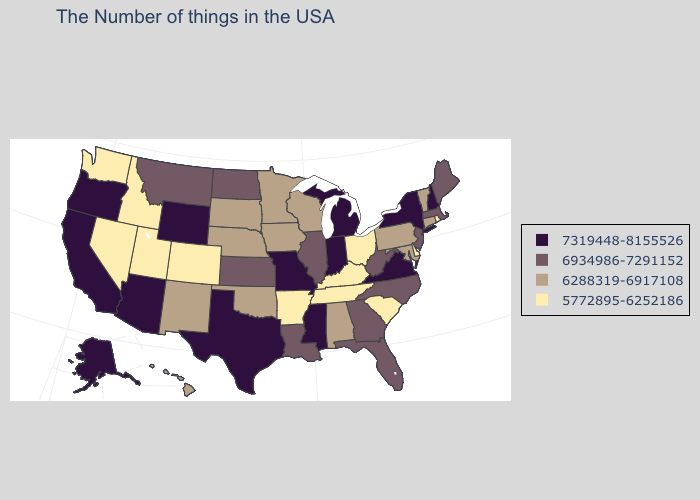Name the states that have a value in the range 5772895-6252186?
Concise answer only. Rhode Island, Delaware, South Carolina, Ohio, Kentucky, Tennessee, Arkansas, Colorado, Utah, Idaho, Nevada, Washington. Name the states that have a value in the range 5772895-6252186?
Be succinct. Rhode Island, Delaware, South Carolina, Ohio, Kentucky, Tennessee, Arkansas, Colorado, Utah, Idaho, Nevada, Washington. Does Hawaii have the highest value in the West?
Give a very brief answer. No. Name the states that have a value in the range 6288319-6917108?
Concise answer only. Vermont, Connecticut, Maryland, Pennsylvania, Alabama, Wisconsin, Minnesota, Iowa, Nebraska, Oklahoma, South Dakota, New Mexico, Hawaii. Does Indiana have the highest value in the USA?
Write a very short answer. Yes. What is the value of South Carolina?
Short answer required. 5772895-6252186. What is the value of Alaska?
Short answer required. 7319448-8155526. Does New Mexico have the lowest value in the West?
Give a very brief answer. No. What is the highest value in the Northeast ?
Concise answer only. 7319448-8155526. Which states hav the highest value in the MidWest?
Short answer required. Michigan, Indiana, Missouri. Name the states that have a value in the range 7319448-8155526?
Give a very brief answer. New Hampshire, New York, Virginia, Michigan, Indiana, Mississippi, Missouri, Texas, Wyoming, Arizona, California, Oregon, Alaska. Name the states that have a value in the range 7319448-8155526?
Keep it brief. New Hampshire, New York, Virginia, Michigan, Indiana, Mississippi, Missouri, Texas, Wyoming, Arizona, California, Oregon, Alaska. What is the value of New York?
Quick response, please. 7319448-8155526. Among the states that border New York , which have the lowest value?
Write a very short answer. Vermont, Connecticut, Pennsylvania. Among the states that border Indiana , does Illinois have the lowest value?
Give a very brief answer. No. 